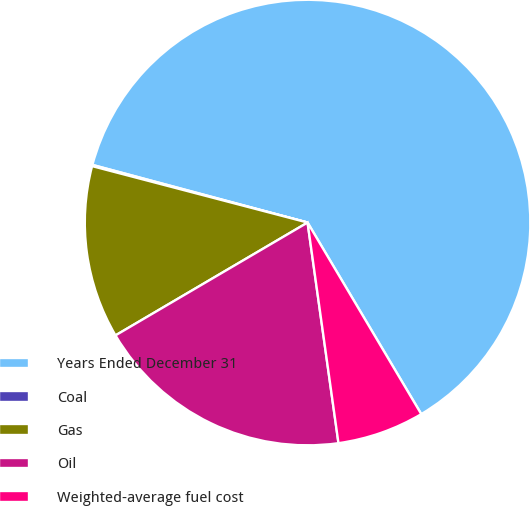Convert chart. <chart><loc_0><loc_0><loc_500><loc_500><pie_chart><fcel>Years Ended December 31<fcel>Coal<fcel>Gas<fcel>Oil<fcel>Weighted-average fuel cost<nl><fcel>62.3%<fcel>0.09%<fcel>12.53%<fcel>18.76%<fcel>6.31%<nl></chart> 